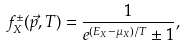Convert formula to latex. <formula><loc_0><loc_0><loc_500><loc_500>f ^ { \pm } _ { X } ( \vec { p } , T ) = \frac { 1 } { e ^ { ( E _ { X } - { \mu } _ { X } ) / T } \pm 1 } ,</formula> 